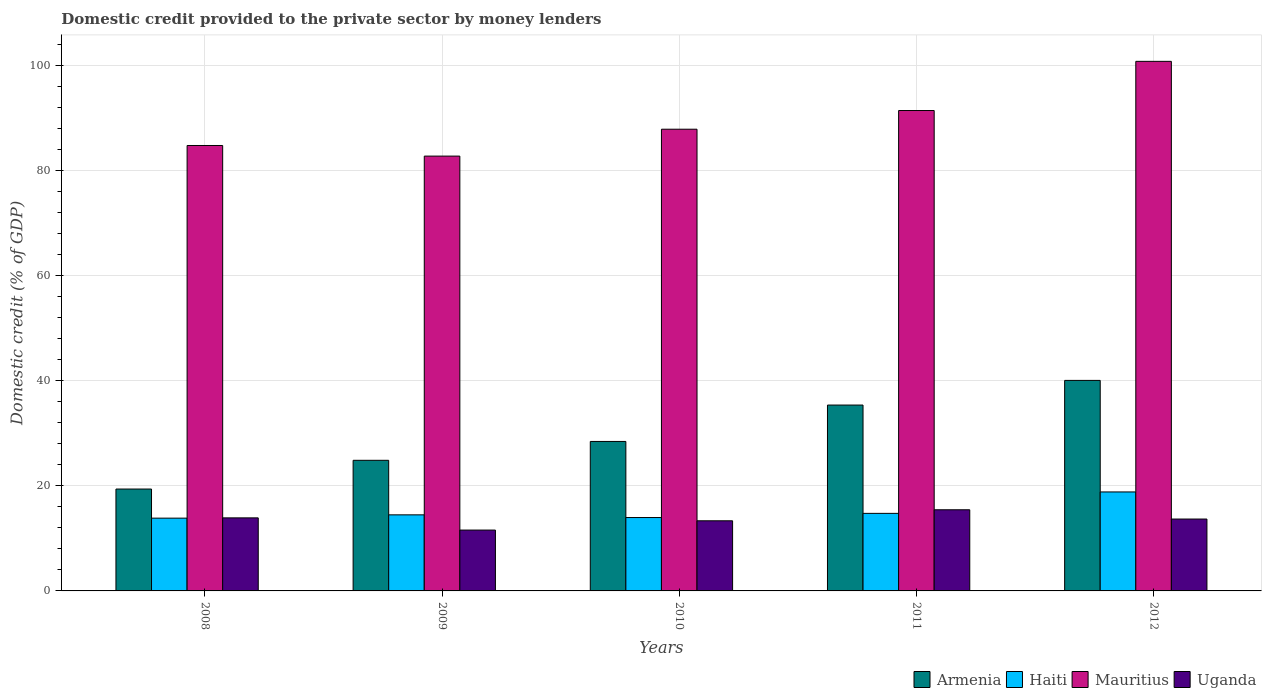How many different coloured bars are there?
Provide a succinct answer. 4. How many groups of bars are there?
Provide a succinct answer. 5. Are the number of bars on each tick of the X-axis equal?
Give a very brief answer. Yes. How many bars are there on the 4th tick from the left?
Provide a succinct answer. 4. In how many cases, is the number of bars for a given year not equal to the number of legend labels?
Offer a very short reply. 0. What is the domestic credit provided to the private sector by money lenders in Haiti in 2010?
Give a very brief answer. 13.97. Across all years, what is the maximum domestic credit provided to the private sector by money lenders in Armenia?
Your response must be concise. 40.06. Across all years, what is the minimum domestic credit provided to the private sector by money lenders in Armenia?
Give a very brief answer. 19.39. In which year was the domestic credit provided to the private sector by money lenders in Mauritius maximum?
Offer a very short reply. 2012. In which year was the domestic credit provided to the private sector by money lenders in Armenia minimum?
Your answer should be compact. 2008. What is the total domestic credit provided to the private sector by money lenders in Mauritius in the graph?
Make the answer very short. 447.56. What is the difference between the domestic credit provided to the private sector by money lenders in Uganda in 2010 and that in 2011?
Provide a short and direct response. -2.1. What is the difference between the domestic credit provided to the private sector by money lenders in Armenia in 2008 and the domestic credit provided to the private sector by money lenders in Uganda in 2009?
Make the answer very short. 7.81. What is the average domestic credit provided to the private sector by money lenders in Mauritius per year?
Make the answer very short. 89.51. In the year 2012, what is the difference between the domestic credit provided to the private sector by money lenders in Uganda and domestic credit provided to the private sector by money lenders in Haiti?
Ensure brevity in your answer.  -5.16. In how many years, is the domestic credit provided to the private sector by money lenders in Mauritius greater than 96 %?
Your answer should be compact. 1. What is the ratio of the domestic credit provided to the private sector by money lenders in Haiti in 2010 to that in 2012?
Your answer should be very brief. 0.74. Is the domestic credit provided to the private sector by money lenders in Haiti in 2008 less than that in 2010?
Your answer should be compact. Yes. Is the difference between the domestic credit provided to the private sector by money lenders in Uganda in 2008 and 2010 greater than the difference between the domestic credit provided to the private sector by money lenders in Haiti in 2008 and 2010?
Provide a short and direct response. Yes. What is the difference between the highest and the second highest domestic credit provided to the private sector by money lenders in Armenia?
Your answer should be very brief. 4.69. What is the difference between the highest and the lowest domestic credit provided to the private sector by money lenders in Uganda?
Provide a succinct answer. 3.86. In how many years, is the domestic credit provided to the private sector by money lenders in Uganda greater than the average domestic credit provided to the private sector by money lenders in Uganda taken over all years?
Your response must be concise. 3. What does the 4th bar from the left in 2012 represents?
Provide a short and direct response. Uganda. What does the 4th bar from the right in 2012 represents?
Your response must be concise. Armenia. Is it the case that in every year, the sum of the domestic credit provided to the private sector by money lenders in Mauritius and domestic credit provided to the private sector by money lenders in Armenia is greater than the domestic credit provided to the private sector by money lenders in Uganda?
Your answer should be very brief. Yes. Where does the legend appear in the graph?
Provide a succinct answer. Bottom right. How are the legend labels stacked?
Provide a short and direct response. Horizontal. What is the title of the graph?
Give a very brief answer. Domestic credit provided to the private sector by money lenders. What is the label or title of the X-axis?
Offer a very short reply. Years. What is the label or title of the Y-axis?
Provide a short and direct response. Domestic credit (% of GDP). What is the Domestic credit (% of GDP) of Armenia in 2008?
Your answer should be compact. 19.39. What is the Domestic credit (% of GDP) in Haiti in 2008?
Your response must be concise. 13.85. What is the Domestic credit (% of GDP) of Mauritius in 2008?
Your response must be concise. 84.76. What is the Domestic credit (% of GDP) of Uganda in 2008?
Your answer should be very brief. 13.9. What is the Domestic credit (% of GDP) of Armenia in 2009?
Keep it short and to the point. 24.85. What is the Domestic credit (% of GDP) of Haiti in 2009?
Your response must be concise. 14.48. What is the Domestic credit (% of GDP) in Mauritius in 2009?
Offer a terse response. 82.74. What is the Domestic credit (% of GDP) of Uganda in 2009?
Give a very brief answer. 11.58. What is the Domestic credit (% of GDP) of Armenia in 2010?
Keep it short and to the point. 28.45. What is the Domestic credit (% of GDP) in Haiti in 2010?
Provide a short and direct response. 13.97. What is the Domestic credit (% of GDP) in Mauritius in 2010?
Ensure brevity in your answer.  87.86. What is the Domestic credit (% of GDP) of Uganda in 2010?
Offer a terse response. 13.34. What is the Domestic credit (% of GDP) of Armenia in 2011?
Provide a short and direct response. 35.37. What is the Domestic credit (% of GDP) in Haiti in 2011?
Your answer should be compact. 14.76. What is the Domestic credit (% of GDP) of Mauritius in 2011?
Your response must be concise. 91.42. What is the Domestic credit (% of GDP) of Uganda in 2011?
Ensure brevity in your answer.  15.44. What is the Domestic credit (% of GDP) of Armenia in 2012?
Give a very brief answer. 40.06. What is the Domestic credit (% of GDP) of Haiti in 2012?
Provide a succinct answer. 18.84. What is the Domestic credit (% of GDP) in Mauritius in 2012?
Give a very brief answer. 100.77. What is the Domestic credit (% of GDP) in Uganda in 2012?
Your response must be concise. 13.68. Across all years, what is the maximum Domestic credit (% of GDP) of Armenia?
Your answer should be very brief. 40.06. Across all years, what is the maximum Domestic credit (% of GDP) of Haiti?
Provide a short and direct response. 18.84. Across all years, what is the maximum Domestic credit (% of GDP) in Mauritius?
Your answer should be very brief. 100.77. Across all years, what is the maximum Domestic credit (% of GDP) of Uganda?
Your answer should be very brief. 15.44. Across all years, what is the minimum Domestic credit (% of GDP) in Armenia?
Give a very brief answer. 19.39. Across all years, what is the minimum Domestic credit (% of GDP) of Haiti?
Offer a terse response. 13.85. Across all years, what is the minimum Domestic credit (% of GDP) of Mauritius?
Make the answer very short. 82.74. Across all years, what is the minimum Domestic credit (% of GDP) of Uganda?
Offer a terse response. 11.58. What is the total Domestic credit (% of GDP) of Armenia in the graph?
Offer a terse response. 148.11. What is the total Domestic credit (% of GDP) in Haiti in the graph?
Ensure brevity in your answer.  75.88. What is the total Domestic credit (% of GDP) in Mauritius in the graph?
Your response must be concise. 447.56. What is the total Domestic credit (% of GDP) in Uganda in the graph?
Provide a short and direct response. 67.94. What is the difference between the Domestic credit (% of GDP) in Armenia in 2008 and that in 2009?
Your answer should be compact. -5.47. What is the difference between the Domestic credit (% of GDP) of Haiti in 2008 and that in 2009?
Offer a terse response. -0.63. What is the difference between the Domestic credit (% of GDP) of Mauritius in 2008 and that in 2009?
Offer a very short reply. 2.02. What is the difference between the Domestic credit (% of GDP) of Uganda in 2008 and that in 2009?
Provide a short and direct response. 2.32. What is the difference between the Domestic credit (% of GDP) in Armenia in 2008 and that in 2010?
Provide a succinct answer. -9.06. What is the difference between the Domestic credit (% of GDP) in Haiti in 2008 and that in 2010?
Your answer should be very brief. -0.12. What is the difference between the Domestic credit (% of GDP) in Mauritius in 2008 and that in 2010?
Your response must be concise. -3.1. What is the difference between the Domestic credit (% of GDP) in Uganda in 2008 and that in 2010?
Ensure brevity in your answer.  0.56. What is the difference between the Domestic credit (% of GDP) of Armenia in 2008 and that in 2011?
Your response must be concise. -15.98. What is the difference between the Domestic credit (% of GDP) in Haiti in 2008 and that in 2011?
Ensure brevity in your answer.  -0.91. What is the difference between the Domestic credit (% of GDP) in Mauritius in 2008 and that in 2011?
Your response must be concise. -6.66. What is the difference between the Domestic credit (% of GDP) of Uganda in 2008 and that in 2011?
Provide a succinct answer. -1.54. What is the difference between the Domestic credit (% of GDP) in Armenia in 2008 and that in 2012?
Provide a succinct answer. -20.67. What is the difference between the Domestic credit (% of GDP) in Haiti in 2008 and that in 2012?
Your answer should be very brief. -4.99. What is the difference between the Domestic credit (% of GDP) of Mauritius in 2008 and that in 2012?
Ensure brevity in your answer.  -16.01. What is the difference between the Domestic credit (% of GDP) in Uganda in 2008 and that in 2012?
Your response must be concise. 0.22. What is the difference between the Domestic credit (% of GDP) in Armenia in 2009 and that in 2010?
Offer a very short reply. -3.59. What is the difference between the Domestic credit (% of GDP) in Haiti in 2009 and that in 2010?
Provide a succinct answer. 0.51. What is the difference between the Domestic credit (% of GDP) in Mauritius in 2009 and that in 2010?
Keep it short and to the point. -5.12. What is the difference between the Domestic credit (% of GDP) in Uganda in 2009 and that in 2010?
Your response must be concise. -1.77. What is the difference between the Domestic credit (% of GDP) of Armenia in 2009 and that in 2011?
Give a very brief answer. -10.51. What is the difference between the Domestic credit (% of GDP) in Haiti in 2009 and that in 2011?
Keep it short and to the point. -0.28. What is the difference between the Domestic credit (% of GDP) of Mauritius in 2009 and that in 2011?
Offer a very short reply. -8.67. What is the difference between the Domestic credit (% of GDP) of Uganda in 2009 and that in 2011?
Offer a very short reply. -3.86. What is the difference between the Domestic credit (% of GDP) in Armenia in 2009 and that in 2012?
Ensure brevity in your answer.  -15.21. What is the difference between the Domestic credit (% of GDP) of Haiti in 2009 and that in 2012?
Provide a succinct answer. -4.36. What is the difference between the Domestic credit (% of GDP) of Mauritius in 2009 and that in 2012?
Your response must be concise. -18.03. What is the difference between the Domestic credit (% of GDP) of Uganda in 2009 and that in 2012?
Keep it short and to the point. -2.1. What is the difference between the Domestic credit (% of GDP) of Armenia in 2010 and that in 2011?
Your answer should be very brief. -6.92. What is the difference between the Domestic credit (% of GDP) in Haiti in 2010 and that in 2011?
Your response must be concise. -0.79. What is the difference between the Domestic credit (% of GDP) in Mauritius in 2010 and that in 2011?
Provide a short and direct response. -3.55. What is the difference between the Domestic credit (% of GDP) in Uganda in 2010 and that in 2011?
Your answer should be compact. -2.1. What is the difference between the Domestic credit (% of GDP) in Armenia in 2010 and that in 2012?
Ensure brevity in your answer.  -11.61. What is the difference between the Domestic credit (% of GDP) of Haiti in 2010 and that in 2012?
Offer a very short reply. -4.87. What is the difference between the Domestic credit (% of GDP) in Mauritius in 2010 and that in 2012?
Ensure brevity in your answer.  -12.91. What is the difference between the Domestic credit (% of GDP) in Uganda in 2010 and that in 2012?
Provide a succinct answer. -0.33. What is the difference between the Domestic credit (% of GDP) in Armenia in 2011 and that in 2012?
Provide a short and direct response. -4.69. What is the difference between the Domestic credit (% of GDP) in Haiti in 2011 and that in 2012?
Ensure brevity in your answer.  -4.08. What is the difference between the Domestic credit (% of GDP) of Mauritius in 2011 and that in 2012?
Your answer should be very brief. -9.36. What is the difference between the Domestic credit (% of GDP) of Uganda in 2011 and that in 2012?
Your answer should be compact. 1.76. What is the difference between the Domestic credit (% of GDP) of Armenia in 2008 and the Domestic credit (% of GDP) of Haiti in 2009?
Offer a terse response. 4.91. What is the difference between the Domestic credit (% of GDP) in Armenia in 2008 and the Domestic credit (% of GDP) in Mauritius in 2009?
Ensure brevity in your answer.  -63.36. What is the difference between the Domestic credit (% of GDP) in Armenia in 2008 and the Domestic credit (% of GDP) in Uganda in 2009?
Give a very brief answer. 7.81. What is the difference between the Domestic credit (% of GDP) of Haiti in 2008 and the Domestic credit (% of GDP) of Mauritius in 2009?
Your answer should be very brief. -68.9. What is the difference between the Domestic credit (% of GDP) in Haiti in 2008 and the Domestic credit (% of GDP) in Uganda in 2009?
Provide a succinct answer. 2.27. What is the difference between the Domestic credit (% of GDP) in Mauritius in 2008 and the Domestic credit (% of GDP) in Uganda in 2009?
Your answer should be compact. 73.18. What is the difference between the Domestic credit (% of GDP) in Armenia in 2008 and the Domestic credit (% of GDP) in Haiti in 2010?
Ensure brevity in your answer.  5.42. What is the difference between the Domestic credit (% of GDP) in Armenia in 2008 and the Domestic credit (% of GDP) in Mauritius in 2010?
Your answer should be very brief. -68.48. What is the difference between the Domestic credit (% of GDP) of Armenia in 2008 and the Domestic credit (% of GDP) of Uganda in 2010?
Your answer should be very brief. 6.04. What is the difference between the Domestic credit (% of GDP) in Haiti in 2008 and the Domestic credit (% of GDP) in Mauritius in 2010?
Your answer should be very brief. -74.01. What is the difference between the Domestic credit (% of GDP) in Haiti in 2008 and the Domestic credit (% of GDP) in Uganda in 2010?
Ensure brevity in your answer.  0.5. What is the difference between the Domestic credit (% of GDP) in Mauritius in 2008 and the Domestic credit (% of GDP) in Uganda in 2010?
Your answer should be very brief. 71.42. What is the difference between the Domestic credit (% of GDP) of Armenia in 2008 and the Domestic credit (% of GDP) of Haiti in 2011?
Your response must be concise. 4.63. What is the difference between the Domestic credit (% of GDP) of Armenia in 2008 and the Domestic credit (% of GDP) of Mauritius in 2011?
Offer a terse response. -72.03. What is the difference between the Domestic credit (% of GDP) in Armenia in 2008 and the Domestic credit (% of GDP) in Uganda in 2011?
Make the answer very short. 3.95. What is the difference between the Domestic credit (% of GDP) in Haiti in 2008 and the Domestic credit (% of GDP) in Mauritius in 2011?
Your answer should be very brief. -77.57. What is the difference between the Domestic credit (% of GDP) of Haiti in 2008 and the Domestic credit (% of GDP) of Uganda in 2011?
Your answer should be very brief. -1.59. What is the difference between the Domestic credit (% of GDP) of Mauritius in 2008 and the Domestic credit (% of GDP) of Uganda in 2011?
Give a very brief answer. 69.32. What is the difference between the Domestic credit (% of GDP) in Armenia in 2008 and the Domestic credit (% of GDP) in Haiti in 2012?
Keep it short and to the point. 0.55. What is the difference between the Domestic credit (% of GDP) in Armenia in 2008 and the Domestic credit (% of GDP) in Mauritius in 2012?
Ensure brevity in your answer.  -81.39. What is the difference between the Domestic credit (% of GDP) of Armenia in 2008 and the Domestic credit (% of GDP) of Uganda in 2012?
Ensure brevity in your answer.  5.71. What is the difference between the Domestic credit (% of GDP) in Haiti in 2008 and the Domestic credit (% of GDP) in Mauritius in 2012?
Offer a terse response. -86.93. What is the difference between the Domestic credit (% of GDP) of Haiti in 2008 and the Domestic credit (% of GDP) of Uganda in 2012?
Offer a very short reply. 0.17. What is the difference between the Domestic credit (% of GDP) of Mauritius in 2008 and the Domestic credit (% of GDP) of Uganda in 2012?
Ensure brevity in your answer.  71.08. What is the difference between the Domestic credit (% of GDP) in Armenia in 2009 and the Domestic credit (% of GDP) in Haiti in 2010?
Provide a succinct answer. 10.89. What is the difference between the Domestic credit (% of GDP) of Armenia in 2009 and the Domestic credit (% of GDP) of Mauritius in 2010?
Make the answer very short. -63.01. What is the difference between the Domestic credit (% of GDP) in Armenia in 2009 and the Domestic credit (% of GDP) in Uganda in 2010?
Your answer should be compact. 11.51. What is the difference between the Domestic credit (% of GDP) of Haiti in 2009 and the Domestic credit (% of GDP) of Mauritius in 2010?
Provide a short and direct response. -73.39. What is the difference between the Domestic credit (% of GDP) in Haiti in 2009 and the Domestic credit (% of GDP) in Uganda in 2010?
Make the answer very short. 1.13. What is the difference between the Domestic credit (% of GDP) in Mauritius in 2009 and the Domestic credit (% of GDP) in Uganda in 2010?
Provide a succinct answer. 69.4. What is the difference between the Domestic credit (% of GDP) in Armenia in 2009 and the Domestic credit (% of GDP) in Haiti in 2011?
Keep it short and to the point. 10.1. What is the difference between the Domestic credit (% of GDP) of Armenia in 2009 and the Domestic credit (% of GDP) of Mauritius in 2011?
Your answer should be very brief. -66.56. What is the difference between the Domestic credit (% of GDP) in Armenia in 2009 and the Domestic credit (% of GDP) in Uganda in 2011?
Ensure brevity in your answer.  9.41. What is the difference between the Domestic credit (% of GDP) of Haiti in 2009 and the Domestic credit (% of GDP) of Mauritius in 2011?
Your answer should be very brief. -76.94. What is the difference between the Domestic credit (% of GDP) in Haiti in 2009 and the Domestic credit (% of GDP) in Uganda in 2011?
Your answer should be compact. -0.97. What is the difference between the Domestic credit (% of GDP) in Mauritius in 2009 and the Domestic credit (% of GDP) in Uganda in 2011?
Offer a very short reply. 67.3. What is the difference between the Domestic credit (% of GDP) of Armenia in 2009 and the Domestic credit (% of GDP) of Haiti in 2012?
Make the answer very short. 6.02. What is the difference between the Domestic credit (% of GDP) in Armenia in 2009 and the Domestic credit (% of GDP) in Mauritius in 2012?
Provide a succinct answer. -75.92. What is the difference between the Domestic credit (% of GDP) in Armenia in 2009 and the Domestic credit (% of GDP) in Uganda in 2012?
Give a very brief answer. 11.18. What is the difference between the Domestic credit (% of GDP) of Haiti in 2009 and the Domestic credit (% of GDP) of Mauritius in 2012?
Your response must be concise. -86.3. What is the difference between the Domestic credit (% of GDP) of Haiti in 2009 and the Domestic credit (% of GDP) of Uganda in 2012?
Offer a terse response. 0.8. What is the difference between the Domestic credit (% of GDP) of Mauritius in 2009 and the Domestic credit (% of GDP) of Uganda in 2012?
Your answer should be very brief. 69.06. What is the difference between the Domestic credit (% of GDP) in Armenia in 2010 and the Domestic credit (% of GDP) in Haiti in 2011?
Your answer should be compact. 13.69. What is the difference between the Domestic credit (% of GDP) of Armenia in 2010 and the Domestic credit (% of GDP) of Mauritius in 2011?
Your answer should be compact. -62.97. What is the difference between the Domestic credit (% of GDP) of Armenia in 2010 and the Domestic credit (% of GDP) of Uganda in 2011?
Provide a short and direct response. 13. What is the difference between the Domestic credit (% of GDP) of Haiti in 2010 and the Domestic credit (% of GDP) of Mauritius in 2011?
Offer a very short reply. -77.45. What is the difference between the Domestic credit (% of GDP) in Haiti in 2010 and the Domestic credit (% of GDP) in Uganda in 2011?
Ensure brevity in your answer.  -1.48. What is the difference between the Domestic credit (% of GDP) of Mauritius in 2010 and the Domestic credit (% of GDP) of Uganda in 2011?
Keep it short and to the point. 72.42. What is the difference between the Domestic credit (% of GDP) of Armenia in 2010 and the Domestic credit (% of GDP) of Haiti in 2012?
Your response must be concise. 9.61. What is the difference between the Domestic credit (% of GDP) in Armenia in 2010 and the Domestic credit (% of GDP) in Mauritius in 2012?
Offer a terse response. -72.33. What is the difference between the Domestic credit (% of GDP) of Armenia in 2010 and the Domestic credit (% of GDP) of Uganda in 2012?
Provide a succinct answer. 14.77. What is the difference between the Domestic credit (% of GDP) in Haiti in 2010 and the Domestic credit (% of GDP) in Mauritius in 2012?
Keep it short and to the point. -86.81. What is the difference between the Domestic credit (% of GDP) in Haiti in 2010 and the Domestic credit (% of GDP) in Uganda in 2012?
Offer a very short reply. 0.29. What is the difference between the Domestic credit (% of GDP) in Mauritius in 2010 and the Domestic credit (% of GDP) in Uganda in 2012?
Offer a terse response. 74.18. What is the difference between the Domestic credit (% of GDP) in Armenia in 2011 and the Domestic credit (% of GDP) in Haiti in 2012?
Make the answer very short. 16.53. What is the difference between the Domestic credit (% of GDP) of Armenia in 2011 and the Domestic credit (% of GDP) of Mauritius in 2012?
Keep it short and to the point. -65.41. What is the difference between the Domestic credit (% of GDP) of Armenia in 2011 and the Domestic credit (% of GDP) of Uganda in 2012?
Give a very brief answer. 21.69. What is the difference between the Domestic credit (% of GDP) in Haiti in 2011 and the Domestic credit (% of GDP) in Mauritius in 2012?
Provide a short and direct response. -86.02. What is the difference between the Domestic credit (% of GDP) in Haiti in 2011 and the Domestic credit (% of GDP) in Uganda in 2012?
Give a very brief answer. 1.08. What is the difference between the Domestic credit (% of GDP) of Mauritius in 2011 and the Domestic credit (% of GDP) of Uganda in 2012?
Your answer should be compact. 77.74. What is the average Domestic credit (% of GDP) in Armenia per year?
Your response must be concise. 29.62. What is the average Domestic credit (% of GDP) of Haiti per year?
Offer a very short reply. 15.18. What is the average Domestic credit (% of GDP) in Mauritius per year?
Give a very brief answer. 89.51. What is the average Domestic credit (% of GDP) of Uganda per year?
Make the answer very short. 13.59. In the year 2008, what is the difference between the Domestic credit (% of GDP) in Armenia and Domestic credit (% of GDP) in Haiti?
Offer a terse response. 5.54. In the year 2008, what is the difference between the Domestic credit (% of GDP) of Armenia and Domestic credit (% of GDP) of Mauritius?
Your response must be concise. -65.37. In the year 2008, what is the difference between the Domestic credit (% of GDP) of Armenia and Domestic credit (% of GDP) of Uganda?
Offer a very short reply. 5.49. In the year 2008, what is the difference between the Domestic credit (% of GDP) of Haiti and Domestic credit (% of GDP) of Mauritius?
Ensure brevity in your answer.  -70.91. In the year 2008, what is the difference between the Domestic credit (% of GDP) of Haiti and Domestic credit (% of GDP) of Uganda?
Your answer should be very brief. -0.05. In the year 2008, what is the difference between the Domestic credit (% of GDP) in Mauritius and Domestic credit (% of GDP) in Uganda?
Make the answer very short. 70.86. In the year 2009, what is the difference between the Domestic credit (% of GDP) in Armenia and Domestic credit (% of GDP) in Haiti?
Your response must be concise. 10.38. In the year 2009, what is the difference between the Domestic credit (% of GDP) in Armenia and Domestic credit (% of GDP) in Mauritius?
Provide a short and direct response. -57.89. In the year 2009, what is the difference between the Domestic credit (% of GDP) of Armenia and Domestic credit (% of GDP) of Uganda?
Provide a succinct answer. 13.28. In the year 2009, what is the difference between the Domestic credit (% of GDP) in Haiti and Domestic credit (% of GDP) in Mauritius?
Your response must be concise. -68.27. In the year 2009, what is the difference between the Domestic credit (% of GDP) in Haiti and Domestic credit (% of GDP) in Uganda?
Ensure brevity in your answer.  2.9. In the year 2009, what is the difference between the Domestic credit (% of GDP) of Mauritius and Domestic credit (% of GDP) of Uganda?
Your answer should be compact. 71.16. In the year 2010, what is the difference between the Domestic credit (% of GDP) in Armenia and Domestic credit (% of GDP) in Haiti?
Keep it short and to the point. 14.48. In the year 2010, what is the difference between the Domestic credit (% of GDP) of Armenia and Domestic credit (% of GDP) of Mauritius?
Your answer should be compact. -59.42. In the year 2010, what is the difference between the Domestic credit (% of GDP) in Armenia and Domestic credit (% of GDP) in Uganda?
Keep it short and to the point. 15.1. In the year 2010, what is the difference between the Domestic credit (% of GDP) of Haiti and Domestic credit (% of GDP) of Mauritius?
Offer a very short reply. -73.9. In the year 2010, what is the difference between the Domestic credit (% of GDP) of Haiti and Domestic credit (% of GDP) of Uganda?
Your response must be concise. 0.62. In the year 2010, what is the difference between the Domestic credit (% of GDP) in Mauritius and Domestic credit (% of GDP) in Uganda?
Ensure brevity in your answer.  74.52. In the year 2011, what is the difference between the Domestic credit (% of GDP) of Armenia and Domestic credit (% of GDP) of Haiti?
Your answer should be compact. 20.61. In the year 2011, what is the difference between the Domestic credit (% of GDP) of Armenia and Domestic credit (% of GDP) of Mauritius?
Offer a very short reply. -56.05. In the year 2011, what is the difference between the Domestic credit (% of GDP) in Armenia and Domestic credit (% of GDP) in Uganda?
Make the answer very short. 19.93. In the year 2011, what is the difference between the Domestic credit (% of GDP) in Haiti and Domestic credit (% of GDP) in Mauritius?
Your answer should be compact. -76.66. In the year 2011, what is the difference between the Domestic credit (% of GDP) in Haiti and Domestic credit (% of GDP) in Uganda?
Offer a very short reply. -0.68. In the year 2011, what is the difference between the Domestic credit (% of GDP) in Mauritius and Domestic credit (% of GDP) in Uganda?
Provide a short and direct response. 75.98. In the year 2012, what is the difference between the Domestic credit (% of GDP) of Armenia and Domestic credit (% of GDP) of Haiti?
Offer a terse response. 21.22. In the year 2012, what is the difference between the Domestic credit (% of GDP) in Armenia and Domestic credit (% of GDP) in Mauritius?
Offer a very short reply. -60.71. In the year 2012, what is the difference between the Domestic credit (% of GDP) of Armenia and Domestic credit (% of GDP) of Uganda?
Make the answer very short. 26.38. In the year 2012, what is the difference between the Domestic credit (% of GDP) in Haiti and Domestic credit (% of GDP) in Mauritius?
Ensure brevity in your answer.  -81.94. In the year 2012, what is the difference between the Domestic credit (% of GDP) of Haiti and Domestic credit (% of GDP) of Uganda?
Your answer should be compact. 5.16. In the year 2012, what is the difference between the Domestic credit (% of GDP) of Mauritius and Domestic credit (% of GDP) of Uganda?
Provide a succinct answer. 87.1. What is the ratio of the Domestic credit (% of GDP) of Armenia in 2008 to that in 2009?
Offer a terse response. 0.78. What is the ratio of the Domestic credit (% of GDP) in Haiti in 2008 to that in 2009?
Keep it short and to the point. 0.96. What is the ratio of the Domestic credit (% of GDP) in Mauritius in 2008 to that in 2009?
Keep it short and to the point. 1.02. What is the ratio of the Domestic credit (% of GDP) in Uganda in 2008 to that in 2009?
Your response must be concise. 1.2. What is the ratio of the Domestic credit (% of GDP) in Armenia in 2008 to that in 2010?
Offer a very short reply. 0.68. What is the ratio of the Domestic credit (% of GDP) of Mauritius in 2008 to that in 2010?
Offer a terse response. 0.96. What is the ratio of the Domestic credit (% of GDP) of Uganda in 2008 to that in 2010?
Offer a terse response. 1.04. What is the ratio of the Domestic credit (% of GDP) of Armenia in 2008 to that in 2011?
Provide a succinct answer. 0.55. What is the ratio of the Domestic credit (% of GDP) of Haiti in 2008 to that in 2011?
Your response must be concise. 0.94. What is the ratio of the Domestic credit (% of GDP) in Mauritius in 2008 to that in 2011?
Offer a very short reply. 0.93. What is the ratio of the Domestic credit (% of GDP) of Uganda in 2008 to that in 2011?
Provide a short and direct response. 0.9. What is the ratio of the Domestic credit (% of GDP) in Armenia in 2008 to that in 2012?
Your answer should be compact. 0.48. What is the ratio of the Domestic credit (% of GDP) of Haiti in 2008 to that in 2012?
Your answer should be compact. 0.74. What is the ratio of the Domestic credit (% of GDP) of Mauritius in 2008 to that in 2012?
Provide a succinct answer. 0.84. What is the ratio of the Domestic credit (% of GDP) in Uganda in 2008 to that in 2012?
Keep it short and to the point. 1.02. What is the ratio of the Domestic credit (% of GDP) of Armenia in 2009 to that in 2010?
Your response must be concise. 0.87. What is the ratio of the Domestic credit (% of GDP) of Haiti in 2009 to that in 2010?
Keep it short and to the point. 1.04. What is the ratio of the Domestic credit (% of GDP) of Mauritius in 2009 to that in 2010?
Your answer should be very brief. 0.94. What is the ratio of the Domestic credit (% of GDP) in Uganda in 2009 to that in 2010?
Your answer should be compact. 0.87. What is the ratio of the Domestic credit (% of GDP) of Armenia in 2009 to that in 2011?
Provide a succinct answer. 0.7. What is the ratio of the Domestic credit (% of GDP) of Haiti in 2009 to that in 2011?
Provide a succinct answer. 0.98. What is the ratio of the Domestic credit (% of GDP) in Mauritius in 2009 to that in 2011?
Offer a very short reply. 0.91. What is the ratio of the Domestic credit (% of GDP) of Uganda in 2009 to that in 2011?
Offer a terse response. 0.75. What is the ratio of the Domestic credit (% of GDP) of Armenia in 2009 to that in 2012?
Give a very brief answer. 0.62. What is the ratio of the Domestic credit (% of GDP) of Haiti in 2009 to that in 2012?
Offer a very short reply. 0.77. What is the ratio of the Domestic credit (% of GDP) in Mauritius in 2009 to that in 2012?
Make the answer very short. 0.82. What is the ratio of the Domestic credit (% of GDP) in Uganda in 2009 to that in 2012?
Provide a short and direct response. 0.85. What is the ratio of the Domestic credit (% of GDP) of Armenia in 2010 to that in 2011?
Make the answer very short. 0.8. What is the ratio of the Domestic credit (% of GDP) of Haiti in 2010 to that in 2011?
Offer a terse response. 0.95. What is the ratio of the Domestic credit (% of GDP) in Mauritius in 2010 to that in 2011?
Keep it short and to the point. 0.96. What is the ratio of the Domestic credit (% of GDP) of Uganda in 2010 to that in 2011?
Give a very brief answer. 0.86. What is the ratio of the Domestic credit (% of GDP) in Armenia in 2010 to that in 2012?
Your answer should be compact. 0.71. What is the ratio of the Domestic credit (% of GDP) of Haiti in 2010 to that in 2012?
Offer a terse response. 0.74. What is the ratio of the Domestic credit (% of GDP) in Mauritius in 2010 to that in 2012?
Keep it short and to the point. 0.87. What is the ratio of the Domestic credit (% of GDP) of Uganda in 2010 to that in 2012?
Offer a terse response. 0.98. What is the ratio of the Domestic credit (% of GDP) of Armenia in 2011 to that in 2012?
Keep it short and to the point. 0.88. What is the ratio of the Domestic credit (% of GDP) in Haiti in 2011 to that in 2012?
Your answer should be compact. 0.78. What is the ratio of the Domestic credit (% of GDP) in Mauritius in 2011 to that in 2012?
Give a very brief answer. 0.91. What is the ratio of the Domestic credit (% of GDP) of Uganda in 2011 to that in 2012?
Your answer should be very brief. 1.13. What is the difference between the highest and the second highest Domestic credit (% of GDP) in Armenia?
Your response must be concise. 4.69. What is the difference between the highest and the second highest Domestic credit (% of GDP) of Haiti?
Offer a terse response. 4.08. What is the difference between the highest and the second highest Domestic credit (% of GDP) of Mauritius?
Provide a succinct answer. 9.36. What is the difference between the highest and the second highest Domestic credit (% of GDP) in Uganda?
Your answer should be compact. 1.54. What is the difference between the highest and the lowest Domestic credit (% of GDP) in Armenia?
Your answer should be compact. 20.67. What is the difference between the highest and the lowest Domestic credit (% of GDP) of Haiti?
Provide a short and direct response. 4.99. What is the difference between the highest and the lowest Domestic credit (% of GDP) in Mauritius?
Provide a succinct answer. 18.03. What is the difference between the highest and the lowest Domestic credit (% of GDP) in Uganda?
Your answer should be compact. 3.86. 